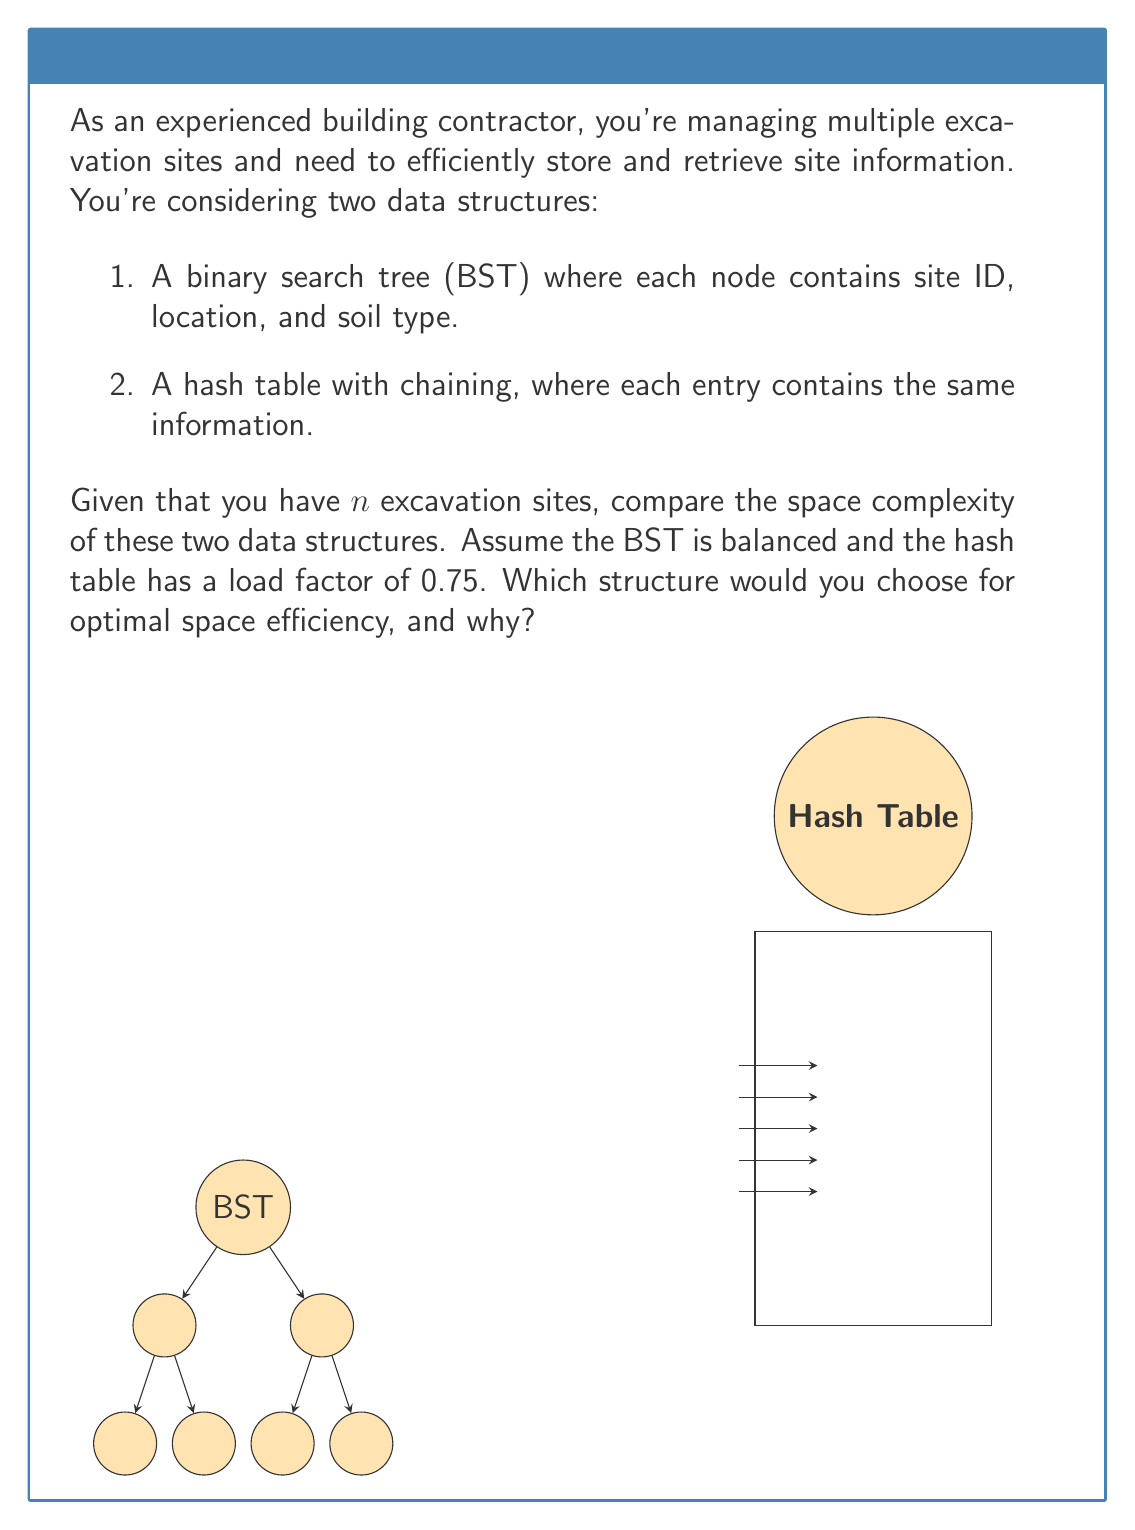Teach me how to tackle this problem. Let's analyze the space complexity of both data structures:

1. Binary Search Tree (BST):
   - Each node in the BST contains:
     * Site ID: $O(1)$ space
     * Location: $O(1)$ space (assuming fixed-size coordinates)
     * Soil type: $O(1)$ space
     * Two pointers (left and right child): $O(1)$ space
   - Total space per node: $O(1)$
   - For $n$ sites, we have $n$ nodes
   - Space complexity of BST: $O(n)$

2. Hash Table with Chaining:
   - Each entry in the hash table contains the same information as a BST node
   - Space per entry: $O(1)$
   - With a load factor of 0.75, the table size is $\frac{n}{0.75} = \frac{4n}{3}$
   - Space for the table: $O(\frac{4n}{3}) = O(n)$
   - Additional space for chaining pointers: $O(n)$
   - Total space complexity: $O(n) + O(n) = O(n)$

Both data structures have a space complexity of $O(n)$, which means they scale linearly with the number of excavation sites.

However, the hash table might use slightly more space in practice due to:
1. The need for extra space to maintain a low load factor (4n/3 vs. n entries)
2. Potential unused slots in the table
3. Additional memory for chaining pointers

The BST, being balanced, would use space more efficiently, with each node directly corresponding to a site and no wasted space.

Therefore, for optimal space efficiency, the balanced BST would be the better choice. It provides $O(\log n)$ time complexity for search, insert, and delete operations, which is suitable for managing excavation site data, while using memory more efficiently than the hash table in this scenario.
Answer: Balanced BST; $O(n)$ space complexity, more space-efficient in practice. 